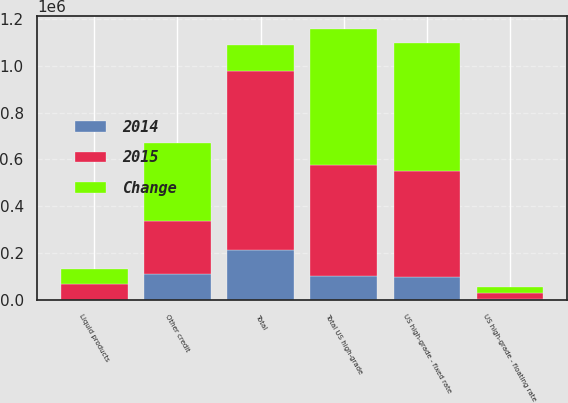<chart> <loc_0><loc_0><loc_500><loc_500><stacked_bar_chart><ecel><fcel>US high-grade - fixed rate<fcel>US high-grade - floating rate<fcel>Total US high-grade<fcel>Other credit<fcel>Liquid products<fcel>Total<nl><fcel>Change<fcel>549086<fcel>28547<fcel>577633<fcel>335513<fcel>65365<fcel>109480<nl><fcel>2015<fcel>450139<fcel>25231<fcel>475370<fcel>226033<fcel>65558<fcel>766961<nl><fcel>2014<fcel>98947<fcel>3316<fcel>102263<fcel>109480<fcel>193<fcel>211550<nl></chart> 